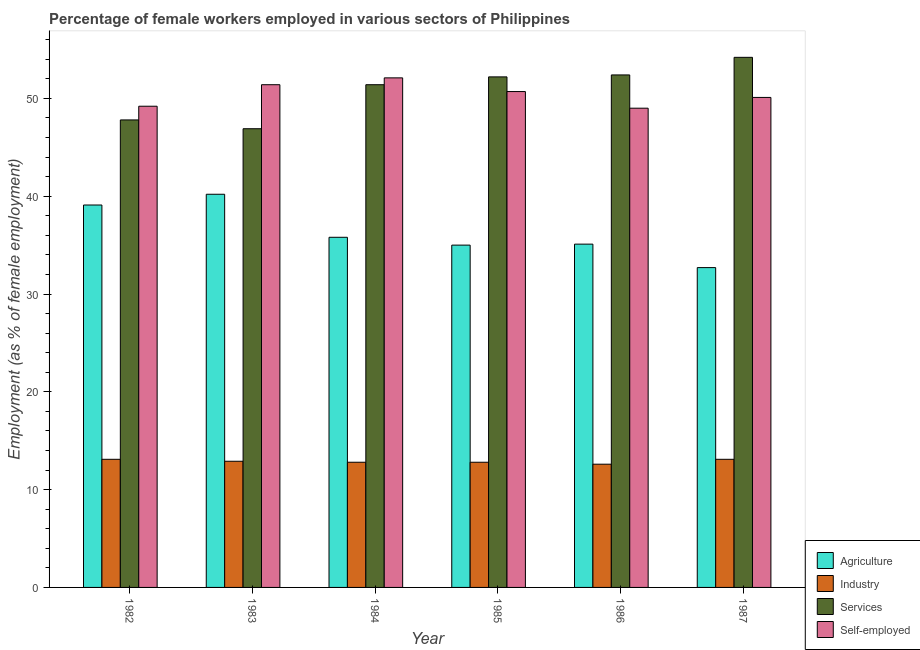How many groups of bars are there?
Offer a very short reply. 6. Are the number of bars per tick equal to the number of legend labels?
Provide a succinct answer. Yes. Are the number of bars on each tick of the X-axis equal?
Make the answer very short. Yes. In how many cases, is the number of bars for a given year not equal to the number of legend labels?
Your answer should be compact. 0. What is the percentage of self employed female workers in 1987?
Offer a very short reply. 50.1. Across all years, what is the maximum percentage of female workers in services?
Offer a very short reply. 54.2. Across all years, what is the minimum percentage of female workers in services?
Provide a short and direct response. 46.9. In which year was the percentage of self employed female workers maximum?
Give a very brief answer. 1984. In which year was the percentage of self employed female workers minimum?
Make the answer very short. 1986. What is the total percentage of self employed female workers in the graph?
Your answer should be very brief. 302.5. What is the difference between the percentage of self employed female workers in 1982 and that in 1983?
Offer a terse response. -2.2. What is the difference between the percentage of female workers in agriculture in 1984 and the percentage of female workers in industry in 1986?
Offer a very short reply. 0.7. What is the average percentage of female workers in industry per year?
Keep it short and to the point. 12.88. What is the ratio of the percentage of female workers in agriculture in 1983 to that in 1984?
Your answer should be very brief. 1.12. Is the difference between the percentage of female workers in industry in 1985 and 1987 greater than the difference between the percentage of self employed female workers in 1985 and 1987?
Ensure brevity in your answer.  No. What is the difference between the highest and the second highest percentage of self employed female workers?
Provide a short and direct response. 0.7. What is the difference between the highest and the lowest percentage of female workers in industry?
Your response must be concise. 0.5. In how many years, is the percentage of female workers in agriculture greater than the average percentage of female workers in agriculture taken over all years?
Offer a very short reply. 2. Is the sum of the percentage of self employed female workers in 1983 and 1985 greater than the maximum percentage of female workers in services across all years?
Your answer should be very brief. Yes. What does the 4th bar from the left in 1984 represents?
Your answer should be very brief. Self-employed. What does the 4th bar from the right in 1985 represents?
Provide a short and direct response. Agriculture. How many bars are there?
Give a very brief answer. 24. Are all the bars in the graph horizontal?
Offer a very short reply. No. What is the difference between two consecutive major ticks on the Y-axis?
Give a very brief answer. 10. Are the values on the major ticks of Y-axis written in scientific E-notation?
Provide a succinct answer. No. Does the graph contain any zero values?
Make the answer very short. No. What is the title of the graph?
Offer a terse response. Percentage of female workers employed in various sectors of Philippines. What is the label or title of the Y-axis?
Keep it short and to the point. Employment (as % of female employment). What is the Employment (as % of female employment) in Agriculture in 1982?
Keep it short and to the point. 39.1. What is the Employment (as % of female employment) in Industry in 1982?
Provide a short and direct response. 13.1. What is the Employment (as % of female employment) in Services in 1982?
Give a very brief answer. 47.8. What is the Employment (as % of female employment) in Self-employed in 1982?
Keep it short and to the point. 49.2. What is the Employment (as % of female employment) of Agriculture in 1983?
Give a very brief answer. 40.2. What is the Employment (as % of female employment) in Industry in 1983?
Offer a very short reply. 12.9. What is the Employment (as % of female employment) in Services in 1983?
Keep it short and to the point. 46.9. What is the Employment (as % of female employment) of Self-employed in 1983?
Your answer should be compact. 51.4. What is the Employment (as % of female employment) of Agriculture in 1984?
Ensure brevity in your answer.  35.8. What is the Employment (as % of female employment) of Industry in 1984?
Provide a succinct answer. 12.8. What is the Employment (as % of female employment) in Services in 1984?
Provide a short and direct response. 51.4. What is the Employment (as % of female employment) of Self-employed in 1984?
Your answer should be compact. 52.1. What is the Employment (as % of female employment) in Industry in 1985?
Your answer should be compact. 12.8. What is the Employment (as % of female employment) in Services in 1985?
Your response must be concise. 52.2. What is the Employment (as % of female employment) in Self-employed in 1985?
Ensure brevity in your answer.  50.7. What is the Employment (as % of female employment) in Agriculture in 1986?
Give a very brief answer. 35.1. What is the Employment (as % of female employment) in Industry in 1986?
Keep it short and to the point. 12.6. What is the Employment (as % of female employment) in Services in 1986?
Provide a succinct answer. 52.4. What is the Employment (as % of female employment) in Agriculture in 1987?
Your answer should be compact. 32.7. What is the Employment (as % of female employment) in Industry in 1987?
Give a very brief answer. 13.1. What is the Employment (as % of female employment) of Services in 1987?
Your response must be concise. 54.2. What is the Employment (as % of female employment) in Self-employed in 1987?
Offer a terse response. 50.1. Across all years, what is the maximum Employment (as % of female employment) of Agriculture?
Your answer should be very brief. 40.2. Across all years, what is the maximum Employment (as % of female employment) of Industry?
Provide a short and direct response. 13.1. Across all years, what is the maximum Employment (as % of female employment) of Services?
Your response must be concise. 54.2. Across all years, what is the maximum Employment (as % of female employment) of Self-employed?
Your answer should be compact. 52.1. Across all years, what is the minimum Employment (as % of female employment) in Agriculture?
Offer a very short reply. 32.7. Across all years, what is the minimum Employment (as % of female employment) of Industry?
Offer a very short reply. 12.6. Across all years, what is the minimum Employment (as % of female employment) of Services?
Provide a short and direct response. 46.9. Across all years, what is the minimum Employment (as % of female employment) of Self-employed?
Keep it short and to the point. 49. What is the total Employment (as % of female employment) of Agriculture in the graph?
Your answer should be compact. 217.9. What is the total Employment (as % of female employment) in Industry in the graph?
Make the answer very short. 77.3. What is the total Employment (as % of female employment) of Services in the graph?
Your answer should be compact. 304.9. What is the total Employment (as % of female employment) of Self-employed in the graph?
Keep it short and to the point. 302.5. What is the difference between the Employment (as % of female employment) of Industry in 1982 and that in 1983?
Ensure brevity in your answer.  0.2. What is the difference between the Employment (as % of female employment) in Services in 1982 and that in 1983?
Provide a succinct answer. 0.9. What is the difference between the Employment (as % of female employment) of Industry in 1982 and that in 1984?
Make the answer very short. 0.3. What is the difference between the Employment (as % of female employment) of Services in 1982 and that in 1984?
Offer a terse response. -3.6. What is the difference between the Employment (as % of female employment) in Agriculture in 1982 and that in 1985?
Provide a succinct answer. 4.1. What is the difference between the Employment (as % of female employment) in Industry in 1982 and that in 1985?
Give a very brief answer. 0.3. What is the difference between the Employment (as % of female employment) of Services in 1982 and that in 1985?
Keep it short and to the point. -4.4. What is the difference between the Employment (as % of female employment) of Self-employed in 1982 and that in 1985?
Provide a succinct answer. -1.5. What is the difference between the Employment (as % of female employment) in Agriculture in 1982 and that in 1986?
Your response must be concise. 4. What is the difference between the Employment (as % of female employment) in Services in 1982 and that in 1986?
Your response must be concise. -4.6. What is the difference between the Employment (as % of female employment) in Self-employed in 1982 and that in 1986?
Provide a succinct answer. 0.2. What is the difference between the Employment (as % of female employment) of Agriculture in 1982 and that in 1987?
Provide a short and direct response. 6.4. What is the difference between the Employment (as % of female employment) of Industry in 1983 and that in 1984?
Your answer should be very brief. 0.1. What is the difference between the Employment (as % of female employment) of Agriculture in 1983 and that in 1985?
Provide a short and direct response. 5.2. What is the difference between the Employment (as % of female employment) of Industry in 1983 and that in 1985?
Provide a short and direct response. 0.1. What is the difference between the Employment (as % of female employment) of Industry in 1983 and that in 1987?
Keep it short and to the point. -0.2. What is the difference between the Employment (as % of female employment) in Services in 1983 and that in 1987?
Ensure brevity in your answer.  -7.3. What is the difference between the Employment (as % of female employment) of Self-employed in 1983 and that in 1987?
Your answer should be very brief. 1.3. What is the difference between the Employment (as % of female employment) in Industry in 1984 and that in 1985?
Make the answer very short. 0. What is the difference between the Employment (as % of female employment) of Agriculture in 1984 and that in 1986?
Your answer should be compact. 0.7. What is the difference between the Employment (as % of female employment) of Self-employed in 1984 and that in 1987?
Provide a succinct answer. 2. What is the difference between the Employment (as % of female employment) of Agriculture in 1985 and that in 1986?
Offer a very short reply. -0.1. What is the difference between the Employment (as % of female employment) in Services in 1985 and that in 1986?
Give a very brief answer. -0.2. What is the difference between the Employment (as % of female employment) in Agriculture in 1985 and that in 1987?
Offer a very short reply. 2.3. What is the difference between the Employment (as % of female employment) in Services in 1985 and that in 1987?
Ensure brevity in your answer.  -2. What is the difference between the Employment (as % of female employment) of Services in 1986 and that in 1987?
Ensure brevity in your answer.  -1.8. What is the difference between the Employment (as % of female employment) of Agriculture in 1982 and the Employment (as % of female employment) of Industry in 1983?
Offer a very short reply. 26.2. What is the difference between the Employment (as % of female employment) in Agriculture in 1982 and the Employment (as % of female employment) in Services in 1983?
Your answer should be compact. -7.8. What is the difference between the Employment (as % of female employment) in Agriculture in 1982 and the Employment (as % of female employment) in Self-employed in 1983?
Keep it short and to the point. -12.3. What is the difference between the Employment (as % of female employment) in Industry in 1982 and the Employment (as % of female employment) in Services in 1983?
Offer a very short reply. -33.8. What is the difference between the Employment (as % of female employment) of Industry in 1982 and the Employment (as % of female employment) of Self-employed in 1983?
Your answer should be compact. -38.3. What is the difference between the Employment (as % of female employment) in Agriculture in 1982 and the Employment (as % of female employment) in Industry in 1984?
Your response must be concise. 26.3. What is the difference between the Employment (as % of female employment) of Agriculture in 1982 and the Employment (as % of female employment) of Services in 1984?
Provide a succinct answer. -12.3. What is the difference between the Employment (as % of female employment) of Industry in 1982 and the Employment (as % of female employment) of Services in 1984?
Your response must be concise. -38.3. What is the difference between the Employment (as % of female employment) in Industry in 1982 and the Employment (as % of female employment) in Self-employed in 1984?
Provide a succinct answer. -39. What is the difference between the Employment (as % of female employment) of Agriculture in 1982 and the Employment (as % of female employment) of Industry in 1985?
Provide a short and direct response. 26.3. What is the difference between the Employment (as % of female employment) of Agriculture in 1982 and the Employment (as % of female employment) of Self-employed in 1985?
Your answer should be very brief. -11.6. What is the difference between the Employment (as % of female employment) of Industry in 1982 and the Employment (as % of female employment) of Services in 1985?
Offer a terse response. -39.1. What is the difference between the Employment (as % of female employment) in Industry in 1982 and the Employment (as % of female employment) in Self-employed in 1985?
Keep it short and to the point. -37.6. What is the difference between the Employment (as % of female employment) in Services in 1982 and the Employment (as % of female employment) in Self-employed in 1985?
Your answer should be very brief. -2.9. What is the difference between the Employment (as % of female employment) of Agriculture in 1982 and the Employment (as % of female employment) of Industry in 1986?
Provide a succinct answer. 26.5. What is the difference between the Employment (as % of female employment) in Agriculture in 1982 and the Employment (as % of female employment) in Self-employed in 1986?
Provide a succinct answer. -9.9. What is the difference between the Employment (as % of female employment) in Industry in 1982 and the Employment (as % of female employment) in Services in 1986?
Give a very brief answer. -39.3. What is the difference between the Employment (as % of female employment) in Industry in 1982 and the Employment (as % of female employment) in Self-employed in 1986?
Your answer should be compact. -35.9. What is the difference between the Employment (as % of female employment) of Services in 1982 and the Employment (as % of female employment) of Self-employed in 1986?
Offer a terse response. -1.2. What is the difference between the Employment (as % of female employment) of Agriculture in 1982 and the Employment (as % of female employment) of Industry in 1987?
Provide a short and direct response. 26. What is the difference between the Employment (as % of female employment) in Agriculture in 1982 and the Employment (as % of female employment) in Services in 1987?
Keep it short and to the point. -15.1. What is the difference between the Employment (as % of female employment) of Industry in 1982 and the Employment (as % of female employment) of Services in 1987?
Offer a very short reply. -41.1. What is the difference between the Employment (as % of female employment) of Industry in 1982 and the Employment (as % of female employment) of Self-employed in 1987?
Your response must be concise. -37. What is the difference between the Employment (as % of female employment) of Agriculture in 1983 and the Employment (as % of female employment) of Industry in 1984?
Give a very brief answer. 27.4. What is the difference between the Employment (as % of female employment) of Agriculture in 1983 and the Employment (as % of female employment) of Services in 1984?
Make the answer very short. -11.2. What is the difference between the Employment (as % of female employment) in Industry in 1983 and the Employment (as % of female employment) in Services in 1984?
Your response must be concise. -38.5. What is the difference between the Employment (as % of female employment) in Industry in 1983 and the Employment (as % of female employment) in Self-employed in 1984?
Offer a very short reply. -39.2. What is the difference between the Employment (as % of female employment) in Agriculture in 1983 and the Employment (as % of female employment) in Industry in 1985?
Provide a succinct answer. 27.4. What is the difference between the Employment (as % of female employment) in Agriculture in 1983 and the Employment (as % of female employment) in Self-employed in 1985?
Ensure brevity in your answer.  -10.5. What is the difference between the Employment (as % of female employment) in Industry in 1983 and the Employment (as % of female employment) in Services in 1985?
Offer a very short reply. -39.3. What is the difference between the Employment (as % of female employment) of Industry in 1983 and the Employment (as % of female employment) of Self-employed in 1985?
Make the answer very short. -37.8. What is the difference between the Employment (as % of female employment) of Services in 1983 and the Employment (as % of female employment) of Self-employed in 1985?
Offer a terse response. -3.8. What is the difference between the Employment (as % of female employment) in Agriculture in 1983 and the Employment (as % of female employment) in Industry in 1986?
Provide a short and direct response. 27.6. What is the difference between the Employment (as % of female employment) of Industry in 1983 and the Employment (as % of female employment) of Services in 1986?
Make the answer very short. -39.5. What is the difference between the Employment (as % of female employment) of Industry in 1983 and the Employment (as % of female employment) of Self-employed in 1986?
Your response must be concise. -36.1. What is the difference between the Employment (as % of female employment) of Agriculture in 1983 and the Employment (as % of female employment) of Industry in 1987?
Your response must be concise. 27.1. What is the difference between the Employment (as % of female employment) in Agriculture in 1983 and the Employment (as % of female employment) in Self-employed in 1987?
Your response must be concise. -9.9. What is the difference between the Employment (as % of female employment) in Industry in 1983 and the Employment (as % of female employment) in Services in 1987?
Ensure brevity in your answer.  -41.3. What is the difference between the Employment (as % of female employment) of Industry in 1983 and the Employment (as % of female employment) of Self-employed in 1987?
Your answer should be compact. -37.2. What is the difference between the Employment (as % of female employment) in Agriculture in 1984 and the Employment (as % of female employment) in Industry in 1985?
Offer a terse response. 23. What is the difference between the Employment (as % of female employment) of Agriculture in 1984 and the Employment (as % of female employment) of Services in 1985?
Offer a terse response. -16.4. What is the difference between the Employment (as % of female employment) of Agriculture in 1984 and the Employment (as % of female employment) of Self-employed in 1985?
Your answer should be compact. -14.9. What is the difference between the Employment (as % of female employment) in Industry in 1984 and the Employment (as % of female employment) in Services in 1985?
Offer a very short reply. -39.4. What is the difference between the Employment (as % of female employment) in Industry in 1984 and the Employment (as % of female employment) in Self-employed in 1985?
Your answer should be very brief. -37.9. What is the difference between the Employment (as % of female employment) of Services in 1984 and the Employment (as % of female employment) of Self-employed in 1985?
Offer a very short reply. 0.7. What is the difference between the Employment (as % of female employment) of Agriculture in 1984 and the Employment (as % of female employment) of Industry in 1986?
Provide a succinct answer. 23.2. What is the difference between the Employment (as % of female employment) in Agriculture in 1984 and the Employment (as % of female employment) in Services in 1986?
Provide a succinct answer. -16.6. What is the difference between the Employment (as % of female employment) of Industry in 1984 and the Employment (as % of female employment) of Services in 1986?
Ensure brevity in your answer.  -39.6. What is the difference between the Employment (as % of female employment) in Industry in 1984 and the Employment (as % of female employment) in Self-employed in 1986?
Offer a very short reply. -36.2. What is the difference between the Employment (as % of female employment) of Agriculture in 1984 and the Employment (as % of female employment) of Industry in 1987?
Your response must be concise. 22.7. What is the difference between the Employment (as % of female employment) in Agriculture in 1984 and the Employment (as % of female employment) in Services in 1987?
Give a very brief answer. -18.4. What is the difference between the Employment (as % of female employment) of Agriculture in 1984 and the Employment (as % of female employment) of Self-employed in 1987?
Give a very brief answer. -14.3. What is the difference between the Employment (as % of female employment) in Industry in 1984 and the Employment (as % of female employment) in Services in 1987?
Your response must be concise. -41.4. What is the difference between the Employment (as % of female employment) in Industry in 1984 and the Employment (as % of female employment) in Self-employed in 1987?
Provide a succinct answer. -37.3. What is the difference between the Employment (as % of female employment) of Agriculture in 1985 and the Employment (as % of female employment) of Industry in 1986?
Ensure brevity in your answer.  22.4. What is the difference between the Employment (as % of female employment) in Agriculture in 1985 and the Employment (as % of female employment) in Services in 1986?
Provide a succinct answer. -17.4. What is the difference between the Employment (as % of female employment) of Industry in 1985 and the Employment (as % of female employment) of Services in 1986?
Provide a succinct answer. -39.6. What is the difference between the Employment (as % of female employment) in Industry in 1985 and the Employment (as % of female employment) in Self-employed in 1986?
Ensure brevity in your answer.  -36.2. What is the difference between the Employment (as % of female employment) of Services in 1985 and the Employment (as % of female employment) of Self-employed in 1986?
Keep it short and to the point. 3.2. What is the difference between the Employment (as % of female employment) in Agriculture in 1985 and the Employment (as % of female employment) in Industry in 1987?
Your answer should be very brief. 21.9. What is the difference between the Employment (as % of female employment) of Agriculture in 1985 and the Employment (as % of female employment) of Services in 1987?
Keep it short and to the point. -19.2. What is the difference between the Employment (as % of female employment) in Agriculture in 1985 and the Employment (as % of female employment) in Self-employed in 1987?
Make the answer very short. -15.1. What is the difference between the Employment (as % of female employment) in Industry in 1985 and the Employment (as % of female employment) in Services in 1987?
Your response must be concise. -41.4. What is the difference between the Employment (as % of female employment) in Industry in 1985 and the Employment (as % of female employment) in Self-employed in 1987?
Provide a succinct answer. -37.3. What is the difference between the Employment (as % of female employment) of Agriculture in 1986 and the Employment (as % of female employment) of Services in 1987?
Your response must be concise. -19.1. What is the difference between the Employment (as % of female employment) in Agriculture in 1986 and the Employment (as % of female employment) in Self-employed in 1987?
Keep it short and to the point. -15. What is the difference between the Employment (as % of female employment) of Industry in 1986 and the Employment (as % of female employment) of Services in 1987?
Offer a very short reply. -41.6. What is the difference between the Employment (as % of female employment) of Industry in 1986 and the Employment (as % of female employment) of Self-employed in 1987?
Your answer should be very brief. -37.5. What is the difference between the Employment (as % of female employment) of Services in 1986 and the Employment (as % of female employment) of Self-employed in 1987?
Keep it short and to the point. 2.3. What is the average Employment (as % of female employment) of Agriculture per year?
Your response must be concise. 36.32. What is the average Employment (as % of female employment) of Industry per year?
Provide a succinct answer. 12.88. What is the average Employment (as % of female employment) of Services per year?
Keep it short and to the point. 50.82. What is the average Employment (as % of female employment) in Self-employed per year?
Make the answer very short. 50.42. In the year 1982, what is the difference between the Employment (as % of female employment) in Agriculture and Employment (as % of female employment) in Services?
Your answer should be compact. -8.7. In the year 1982, what is the difference between the Employment (as % of female employment) in Agriculture and Employment (as % of female employment) in Self-employed?
Give a very brief answer. -10.1. In the year 1982, what is the difference between the Employment (as % of female employment) in Industry and Employment (as % of female employment) in Services?
Your answer should be very brief. -34.7. In the year 1982, what is the difference between the Employment (as % of female employment) of Industry and Employment (as % of female employment) of Self-employed?
Keep it short and to the point. -36.1. In the year 1983, what is the difference between the Employment (as % of female employment) of Agriculture and Employment (as % of female employment) of Industry?
Offer a terse response. 27.3. In the year 1983, what is the difference between the Employment (as % of female employment) of Industry and Employment (as % of female employment) of Services?
Provide a succinct answer. -34. In the year 1983, what is the difference between the Employment (as % of female employment) of Industry and Employment (as % of female employment) of Self-employed?
Keep it short and to the point. -38.5. In the year 1984, what is the difference between the Employment (as % of female employment) of Agriculture and Employment (as % of female employment) of Industry?
Your response must be concise. 23. In the year 1984, what is the difference between the Employment (as % of female employment) of Agriculture and Employment (as % of female employment) of Services?
Your answer should be very brief. -15.6. In the year 1984, what is the difference between the Employment (as % of female employment) of Agriculture and Employment (as % of female employment) of Self-employed?
Ensure brevity in your answer.  -16.3. In the year 1984, what is the difference between the Employment (as % of female employment) in Industry and Employment (as % of female employment) in Services?
Make the answer very short. -38.6. In the year 1984, what is the difference between the Employment (as % of female employment) in Industry and Employment (as % of female employment) in Self-employed?
Provide a succinct answer. -39.3. In the year 1984, what is the difference between the Employment (as % of female employment) of Services and Employment (as % of female employment) of Self-employed?
Provide a succinct answer. -0.7. In the year 1985, what is the difference between the Employment (as % of female employment) of Agriculture and Employment (as % of female employment) of Industry?
Ensure brevity in your answer.  22.2. In the year 1985, what is the difference between the Employment (as % of female employment) of Agriculture and Employment (as % of female employment) of Services?
Your answer should be very brief. -17.2. In the year 1985, what is the difference between the Employment (as % of female employment) in Agriculture and Employment (as % of female employment) in Self-employed?
Offer a very short reply. -15.7. In the year 1985, what is the difference between the Employment (as % of female employment) in Industry and Employment (as % of female employment) in Services?
Your answer should be very brief. -39.4. In the year 1985, what is the difference between the Employment (as % of female employment) of Industry and Employment (as % of female employment) of Self-employed?
Ensure brevity in your answer.  -37.9. In the year 1986, what is the difference between the Employment (as % of female employment) of Agriculture and Employment (as % of female employment) of Industry?
Make the answer very short. 22.5. In the year 1986, what is the difference between the Employment (as % of female employment) in Agriculture and Employment (as % of female employment) in Services?
Offer a very short reply. -17.3. In the year 1986, what is the difference between the Employment (as % of female employment) of Industry and Employment (as % of female employment) of Services?
Keep it short and to the point. -39.8. In the year 1986, what is the difference between the Employment (as % of female employment) in Industry and Employment (as % of female employment) in Self-employed?
Offer a very short reply. -36.4. In the year 1986, what is the difference between the Employment (as % of female employment) in Services and Employment (as % of female employment) in Self-employed?
Provide a succinct answer. 3.4. In the year 1987, what is the difference between the Employment (as % of female employment) in Agriculture and Employment (as % of female employment) in Industry?
Make the answer very short. 19.6. In the year 1987, what is the difference between the Employment (as % of female employment) of Agriculture and Employment (as % of female employment) of Services?
Give a very brief answer. -21.5. In the year 1987, what is the difference between the Employment (as % of female employment) in Agriculture and Employment (as % of female employment) in Self-employed?
Provide a short and direct response. -17.4. In the year 1987, what is the difference between the Employment (as % of female employment) in Industry and Employment (as % of female employment) in Services?
Provide a succinct answer. -41.1. In the year 1987, what is the difference between the Employment (as % of female employment) in Industry and Employment (as % of female employment) in Self-employed?
Make the answer very short. -37. In the year 1987, what is the difference between the Employment (as % of female employment) of Services and Employment (as % of female employment) of Self-employed?
Ensure brevity in your answer.  4.1. What is the ratio of the Employment (as % of female employment) of Agriculture in 1982 to that in 1983?
Offer a terse response. 0.97. What is the ratio of the Employment (as % of female employment) in Industry in 1982 to that in 1983?
Your answer should be compact. 1.02. What is the ratio of the Employment (as % of female employment) of Services in 1982 to that in 1983?
Give a very brief answer. 1.02. What is the ratio of the Employment (as % of female employment) in Self-employed in 1982 to that in 1983?
Keep it short and to the point. 0.96. What is the ratio of the Employment (as % of female employment) of Agriculture in 1982 to that in 1984?
Offer a terse response. 1.09. What is the ratio of the Employment (as % of female employment) of Industry in 1982 to that in 1984?
Keep it short and to the point. 1.02. What is the ratio of the Employment (as % of female employment) of Services in 1982 to that in 1984?
Your answer should be very brief. 0.93. What is the ratio of the Employment (as % of female employment) of Self-employed in 1982 to that in 1984?
Keep it short and to the point. 0.94. What is the ratio of the Employment (as % of female employment) in Agriculture in 1982 to that in 1985?
Provide a short and direct response. 1.12. What is the ratio of the Employment (as % of female employment) in Industry in 1982 to that in 1985?
Your answer should be compact. 1.02. What is the ratio of the Employment (as % of female employment) of Services in 1982 to that in 1985?
Ensure brevity in your answer.  0.92. What is the ratio of the Employment (as % of female employment) of Self-employed in 1982 to that in 1985?
Your answer should be compact. 0.97. What is the ratio of the Employment (as % of female employment) in Agriculture in 1982 to that in 1986?
Give a very brief answer. 1.11. What is the ratio of the Employment (as % of female employment) of Industry in 1982 to that in 1986?
Your answer should be compact. 1.04. What is the ratio of the Employment (as % of female employment) in Services in 1982 to that in 1986?
Offer a very short reply. 0.91. What is the ratio of the Employment (as % of female employment) in Self-employed in 1982 to that in 1986?
Provide a short and direct response. 1. What is the ratio of the Employment (as % of female employment) of Agriculture in 1982 to that in 1987?
Keep it short and to the point. 1.2. What is the ratio of the Employment (as % of female employment) of Industry in 1982 to that in 1987?
Give a very brief answer. 1. What is the ratio of the Employment (as % of female employment) of Services in 1982 to that in 1987?
Provide a succinct answer. 0.88. What is the ratio of the Employment (as % of female employment) of Agriculture in 1983 to that in 1984?
Provide a succinct answer. 1.12. What is the ratio of the Employment (as % of female employment) in Services in 1983 to that in 1984?
Your answer should be compact. 0.91. What is the ratio of the Employment (as % of female employment) of Self-employed in 1983 to that in 1984?
Give a very brief answer. 0.99. What is the ratio of the Employment (as % of female employment) in Agriculture in 1983 to that in 1985?
Provide a succinct answer. 1.15. What is the ratio of the Employment (as % of female employment) in Industry in 1983 to that in 1985?
Your response must be concise. 1.01. What is the ratio of the Employment (as % of female employment) in Services in 1983 to that in 1985?
Offer a very short reply. 0.9. What is the ratio of the Employment (as % of female employment) of Self-employed in 1983 to that in 1985?
Provide a succinct answer. 1.01. What is the ratio of the Employment (as % of female employment) in Agriculture in 1983 to that in 1986?
Give a very brief answer. 1.15. What is the ratio of the Employment (as % of female employment) of Industry in 1983 to that in 1986?
Your response must be concise. 1.02. What is the ratio of the Employment (as % of female employment) in Services in 1983 to that in 1986?
Your answer should be compact. 0.9. What is the ratio of the Employment (as % of female employment) of Self-employed in 1983 to that in 1986?
Keep it short and to the point. 1.05. What is the ratio of the Employment (as % of female employment) of Agriculture in 1983 to that in 1987?
Your answer should be compact. 1.23. What is the ratio of the Employment (as % of female employment) of Industry in 1983 to that in 1987?
Provide a short and direct response. 0.98. What is the ratio of the Employment (as % of female employment) of Services in 1983 to that in 1987?
Your answer should be compact. 0.87. What is the ratio of the Employment (as % of female employment) in Self-employed in 1983 to that in 1987?
Provide a succinct answer. 1.03. What is the ratio of the Employment (as % of female employment) in Agriculture in 1984 to that in 1985?
Keep it short and to the point. 1.02. What is the ratio of the Employment (as % of female employment) in Services in 1984 to that in 1985?
Ensure brevity in your answer.  0.98. What is the ratio of the Employment (as % of female employment) of Self-employed in 1984 to that in 1985?
Your response must be concise. 1.03. What is the ratio of the Employment (as % of female employment) of Agriculture in 1984 to that in 1986?
Provide a succinct answer. 1.02. What is the ratio of the Employment (as % of female employment) of Industry in 1984 to that in 1986?
Offer a terse response. 1.02. What is the ratio of the Employment (as % of female employment) in Services in 1984 to that in 1986?
Give a very brief answer. 0.98. What is the ratio of the Employment (as % of female employment) in Self-employed in 1984 to that in 1986?
Offer a very short reply. 1.06. What is the ratio of the Employment (as % of female employment) in Agriculture in 1984 to that in 1987?
Provide a succinct answer. 1.09. What is the ratio of the Employment (as % of female employment) of Industry in 1984 to that in 1987?
Your answer should be very brief. 0.98. What is the ratio of the Employment (as % of female employment) in Services in 1984 to that in 1987?
Give a very brief answer. 0.95. What is the ratio of the Employment (as % of female employment) of Self-employed in 1984 to that in 1987?
Keep it short and to the point. 1.04. What is the ratio of the Employment (as % of female employment) of Agriculture in 1985 to that in 1986?
Offer a very short reply. 1. What is the ratio of the Employment (as % of female employment) in Industry in 1985 to that in 1986?
Offer a very short reply. 1.02. What is the ratio of the Employment (as % of female employment) of Self-employed in 1985 to that in 1986?
Provide a succinct answer. 1.03. What is the ratio of the Employment (as % of female employment) in Agriculture in 1985 to that in 1987?
Ensure brevity in your answer.  1.07. What is the ratio of the Employment (as % of female employment) of Industry in 1985 to that in 1987?
Your answer should be very brief. 0.98. What is the ratio of the Employment (as % of female employment) in Services in 1985 to that in 1987?
Make the answer very short. 0.96. What is the ratio of the Employment (as % of female employment) in Self-employed in 1985 to that in 1987?
Your answer should be compact. 1.01. What is the ratio of the Employment (as % of female employment) in Agriculture in 1986 to that in 1987?
Your response must be concise. 1.07. What is the ratio of the Employment (as % of female employment) in Industry in 1986 to that in 1987?
Provide a short and direct response. 0.96. What is the ratio of the Employment (as % of female employment) of Services in 1986 to that in 1987?
Your answer should be very brief. 0.97. What is the difference between the highest and the second highest Employment (as % of female employment) in Agriculture?
Ensure brevity in your answer.  1.1. What is the difference between the highest and the second highest Employment (as % of female employment) of Industry?
Provide a short and direct response. 0. What is the difference between the highest and the lowest Employment (as % of female employment) in Industry?
Ensure brevity in your answer.  0.5. What is the difference between the highest and the lowest Employment (as % of female employment) in Services?
Your answer should be compact. 7.3. What is the difference between the highest and the lowest Employment (as % of female employment) of Self-employed?
Your answer should be compact. 3.1. 